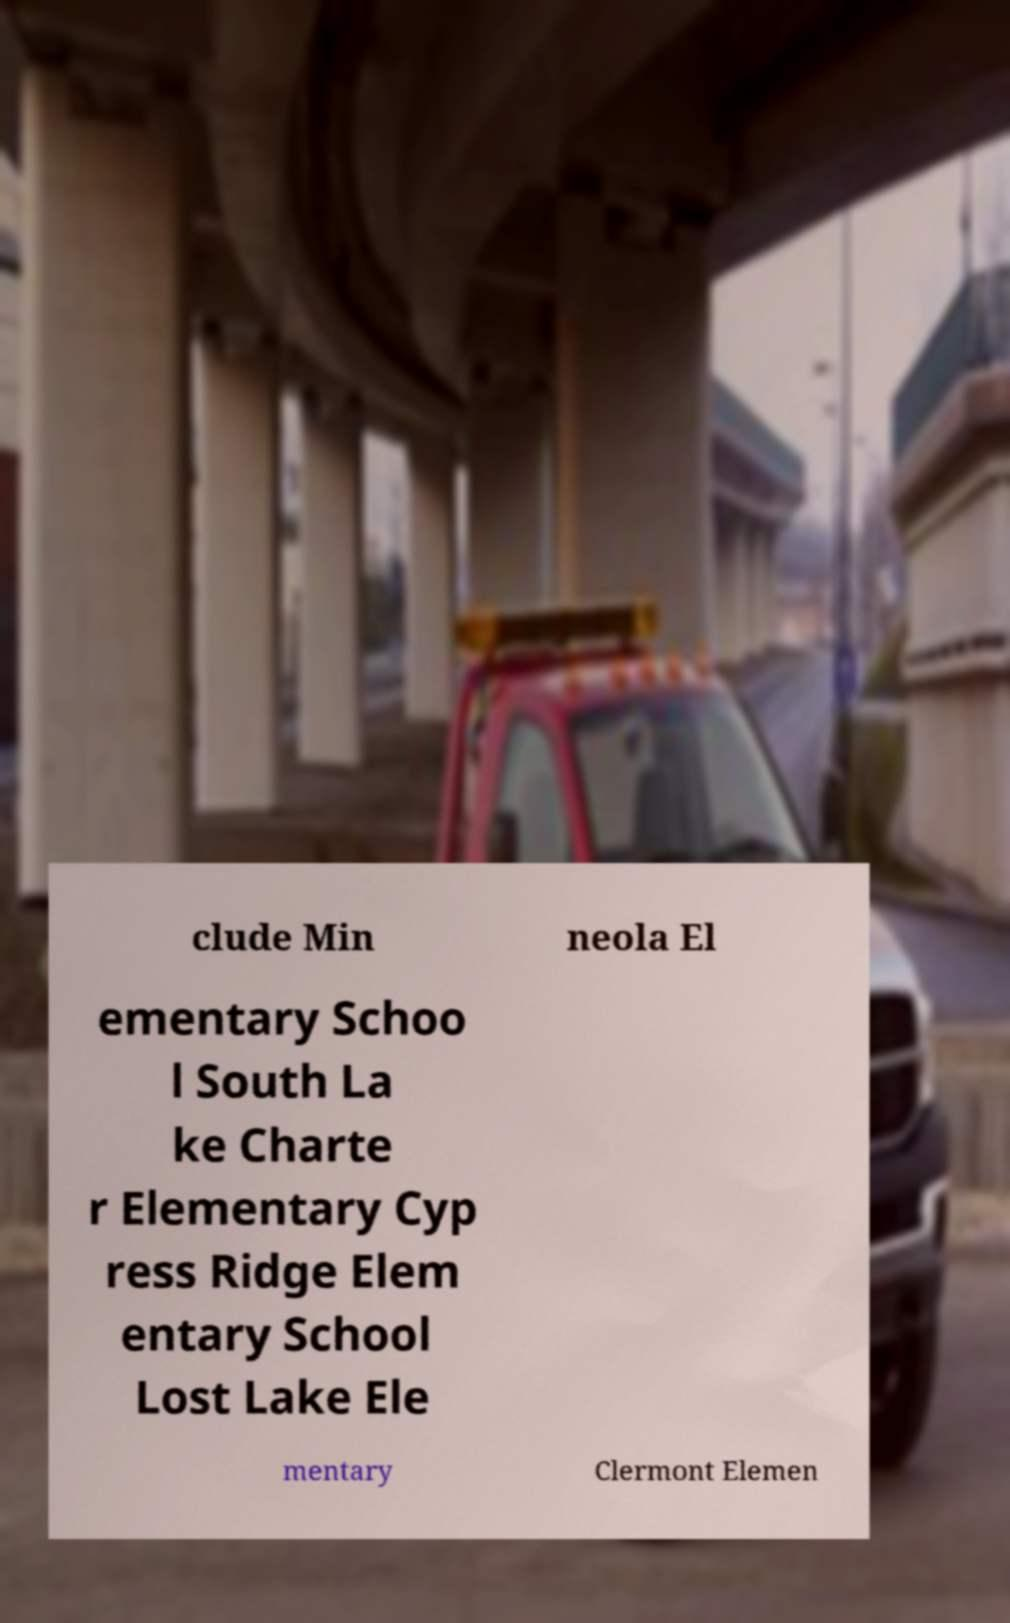Could you extract and type out the text from this image? clude Min neola El ementary Schoo l South La ke Charte r Elementary Cyp ress Ridge Elem entary School Lost Lake Ele mentary Clermont Elemen 